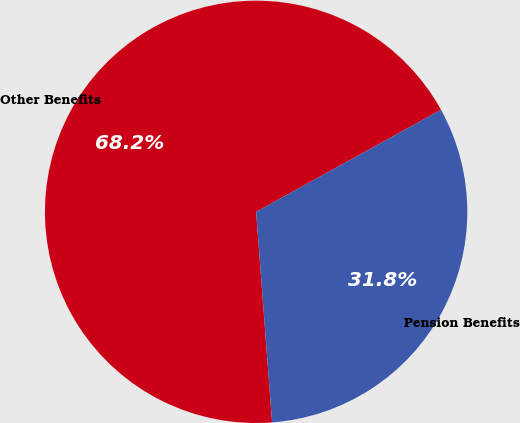<chart> <loc_0><loc_0><loc_500><loc_500><pie_chart><fcel>Other Benefits<fcel>Pension Benefits<nl><fcel>68.18%<fcel>31.82%<nl></chart> 